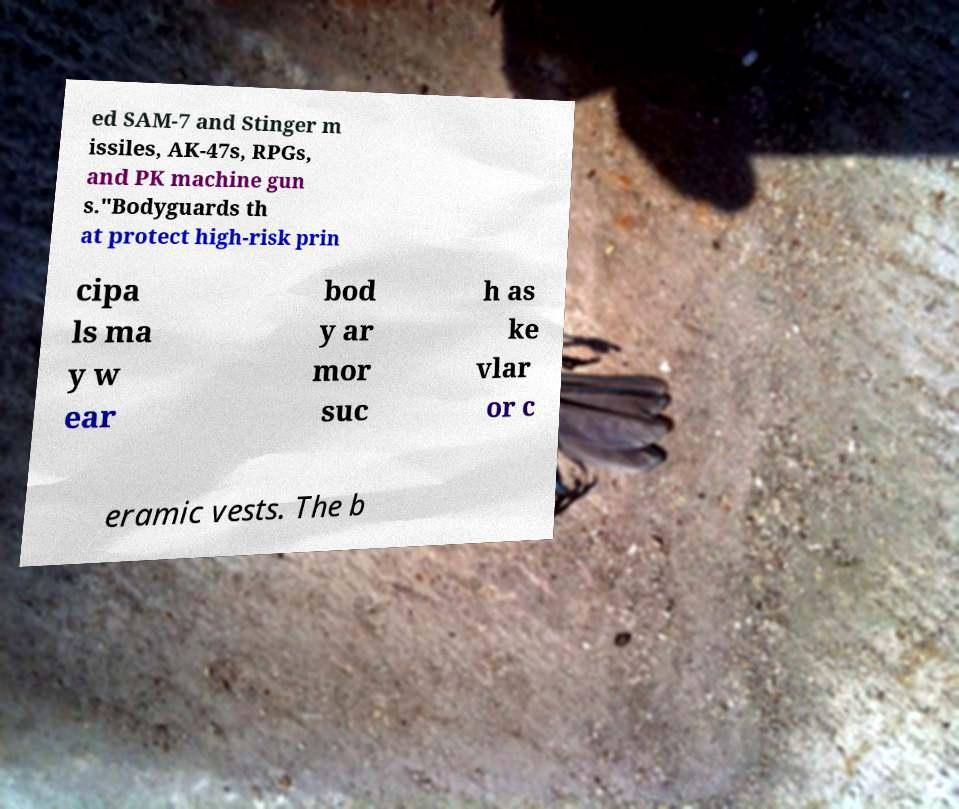Can you read and provide the text displayed in the image?This photo seems to have some interesting text. Can you extract and type it out for me? ed SAM-7 and Stinger m issiles, AK-47s, RPGs, and PK machine gun s."Bodyguards th at protect high-risk prin cipa ls ma y w ear bod y ar mor suc h as ke vlar or c eramic vests. The b 